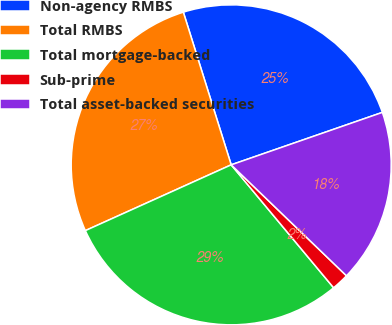<chart> <loc_0><loc_0><loc_500><loc_500><pie_chart><fcel>Non-agency RMBS<fcel>Total RMBS<fcel>Total mortgage-backed<fcel>Sub-prime<fcel>Total asset-backed securities<nl><fcel>24.52%<fcel>26.91%<fcel>29.31%<fcel>1.75%<fcel>17.51%<nl></chart> 